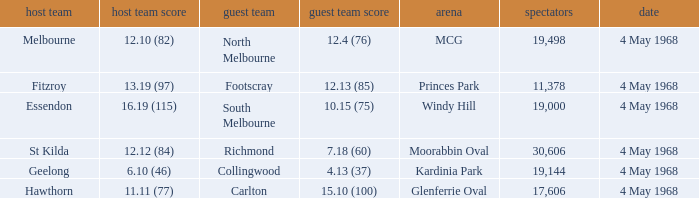What away team played at Kardinia Park? 4.13 (37). 